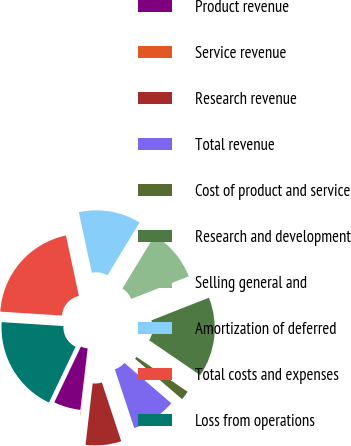<chart> <loc_0><loc_0><loc_500><loc_500><pie_chart><fcel>Product revenue<fcel>Service revenue<fcel>Research revenue<fcel>Total revenue<fcel>Cost of product and service<fcel>Research and development<fcel>Selling general and<fcel>Amortization of deferred<fcel>Total costs and expenses<fcel>Loss from operations<nl><fcel>5.2%<fcel>0.05%<fcel>6.91%<fcel>8.63%<fcel>1.77%<fcel>15.49%<fcel>10.34%<fcel>12.06%<fcel>20.63%<fcel>18.92%<nl></chart> 